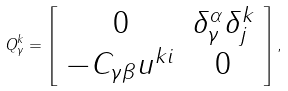Convert formula to latex. <formula><loc_0><loc_0><loc_500><loc_500>Q _ { \gamma } ^ { k } = \left [ \begin{array} { c c } { 0 } & { { \delta _ { \gamma } ^ { \alpha } \delta _ { j } ^ { k } } } \\ { { - C _ { \gamma \beta } u ^ { k i } } } & { 0 } \end{array} \right ] ,</formula> 